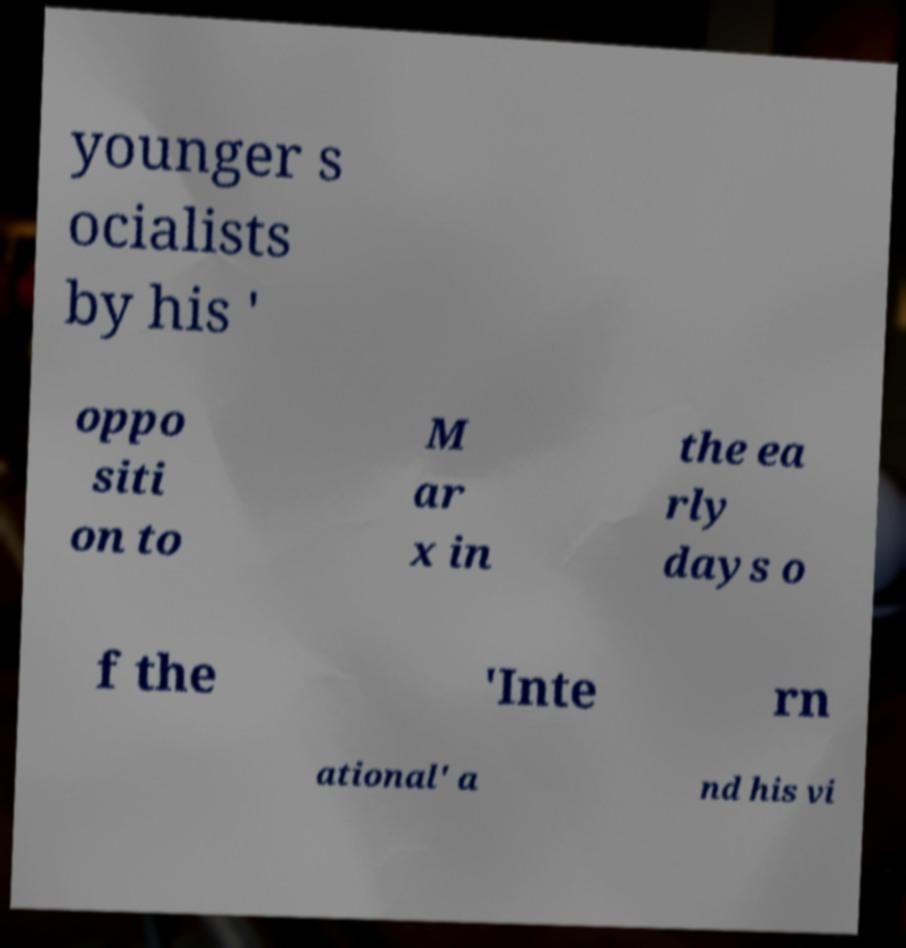Please read and relay the text visible in this image. What does it say? younger s ocialists by his ' oppo siti on to M ar x in the ea rly days o f the 'Inte rn ational' a nd his vi 